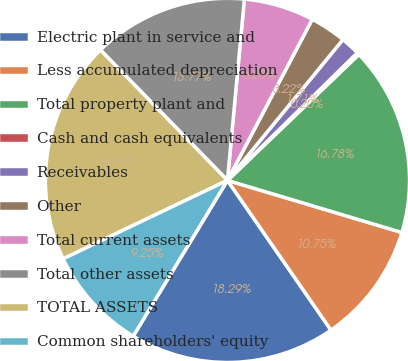Convert chart. <chart><loc_0><loc_0><loc_500><loc_500><pie_chart><fcel>Electric plant in service and<fcel>Less accumulated depreciation<fcel>Total property plant and<fcel>Cash and cash equivalents<fcel>Receivables<fcel>Other<fcel>Total current assets<fcel>Total other assets<fcel>TOTAL ASSETS<fcel>Common shareholders' equity<nl><fcel>18.29%<fcel>10.75%<fcel>16.78%<fcel>0.2%<fcel>1.71%<fcel>3.22%<fcel>6.23%<fcel>13.77%<fcel>19.8%<fcel>9.25%<nl></chart> 